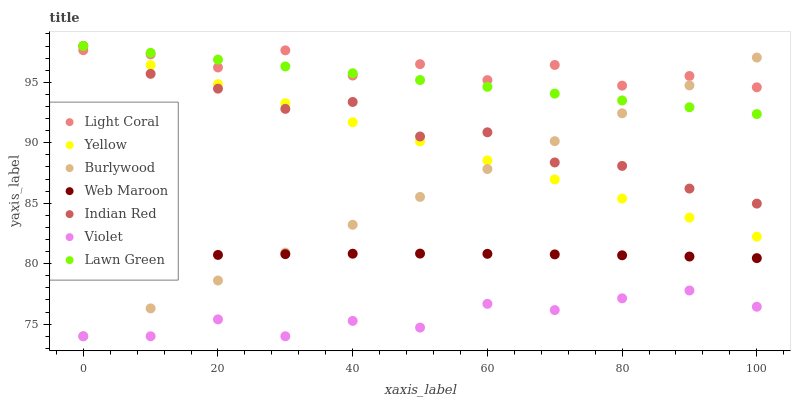Does Violet have the minimum area under the curve?
Answer yes or no. Yes. Does Light Coral have the maximum area under the curve?
Answer yes or no. Yes. Does Burlywood have the minimum area under the curve?
Answer yes or no. No. Does Burlywood have the maximum area under the curve?
Answer yes or no. No. Is Yellow the smoothest?
Answer yes or no. Yes. Is Light Coral the roughest?
Answer yes or no. Yes. Is Burlywood the smoothest?
Answer yes or no. No. Is Burlywood the roughest?
Answer yes or no. No. Does Burlywood have the lowest value?
Answer yes or no. Yes. Does Web Maroon have the lowest value?
Answer yes or no. No. Does Indian Red have the highest value?
Answer yes or no. Yes. Does Burlywood have the highest value?
Answer yes or no. No. Is Web Maroon less than Light Coral?
Answer yes or no. Yes. Is Indian Red greater than Violet?
Answer yes or no. Yes. Does Indian Red intersect Burlywood?
Answer yes or no. Yes. Is Indian Red less than Burlywood?
Answer yes or no. No. Is Indian Red greater than Burlywood?
Answer yes or no. No. Does Web Maroon intersect Light Coral?
Answer yes or no. No. 